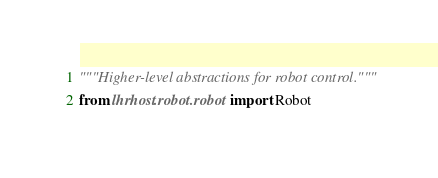Convert code to text. <code><loc_0><loc_0><loc_500><loc_500><_Python_>"""Higher-level abstractions for robot control."""
from lhrhost.robot.robot import Robot
</code> 